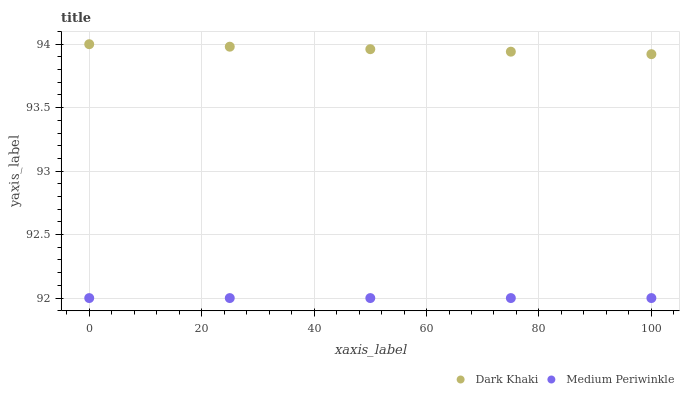Does Medium Periwinkle have the minimum area under the curve?
Answer yes or no. Yes. Does Dark Khaki have the maximum area under the curve?
Answer yes or no. Yes. Does Medium Periwinkle have the maximum area under the curve?
Answer yes or no. No. Is Medium Periwinkle the smoothest?
Answer yes or no. Yes. Is Dark Khaki the roughest?
Answer yes or no. Yes. Is Medium Periwinkle the roughest?
Answer yes or no. No. Does Medium Periwinkle have the lowest value?
Answer yes or no. Yes. Does Dark Khaki have the highest value?
Answer yes or no. Yes. Does Medium Periwinkle have the highest value?
Answer yes or no. No. Is Medium Periwinkle less than Dark Khaki?
Answer yes or no. Yes. Is Dark Khaki greater than Medium Periwinkle?
Answer yes or no. Yes. Does Medium Periwinkle intersect Dark Khaki?
Answer yes or no. No. 